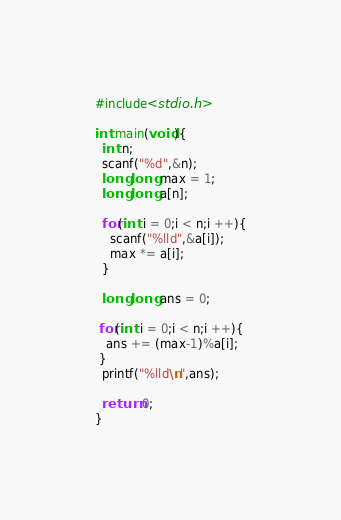Convert code to text. <code><loc_0><loc_0><loc_500><loc_500><_C_>#include<stdio.h>

int main(void){
  int n;
  scanf("%d",&n);
  long long max = 1;  
  long long a[n];
  
  for(int i = 0;i < n;i ++){
    scanf("%lld",&a[i]);
    max *= a[i]; 
  }
  
  long long ans = 0;
  
 for(int i = 0;i < n;i ++){
   ans += (max-1)%a[i];
 }
  printf("%lld\n",ans);
  
  return 0;
}</code> 